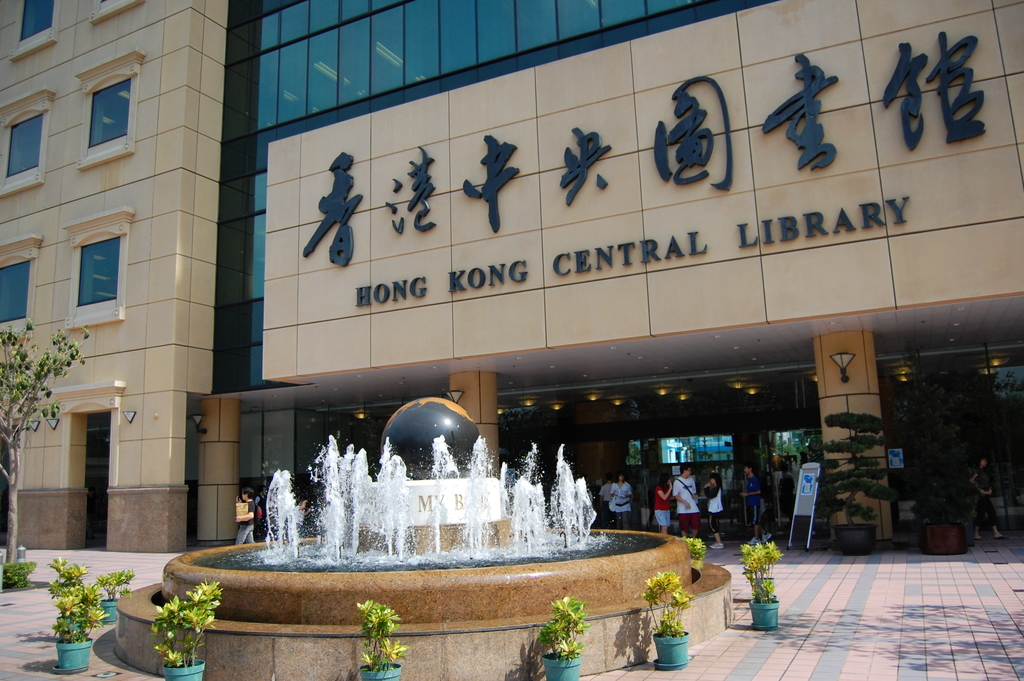Write a detailed description of the given image. The image features the Hong Kong Central Library, a prominent public building known for its modern architectural style. At the forefront, there's a large fountain with a shiny black spherical sculpture from which jets of water gush upward, creating a dynamic water display. The entrance of the library is marked by sizeable golden Chinese characters that read '
9996
6e2f
4e2d
592e
56fe
4e66
9986' (Hong Kong Central Library in Chinese), with the English translation prominently displayed below. The scene captures a vibrant day, with individuals and small groups hovering near the entrance, likely patrons coming and going. Potted green plants add a refreshing touch to the beige stone plaza, enhancing the urban public space. 